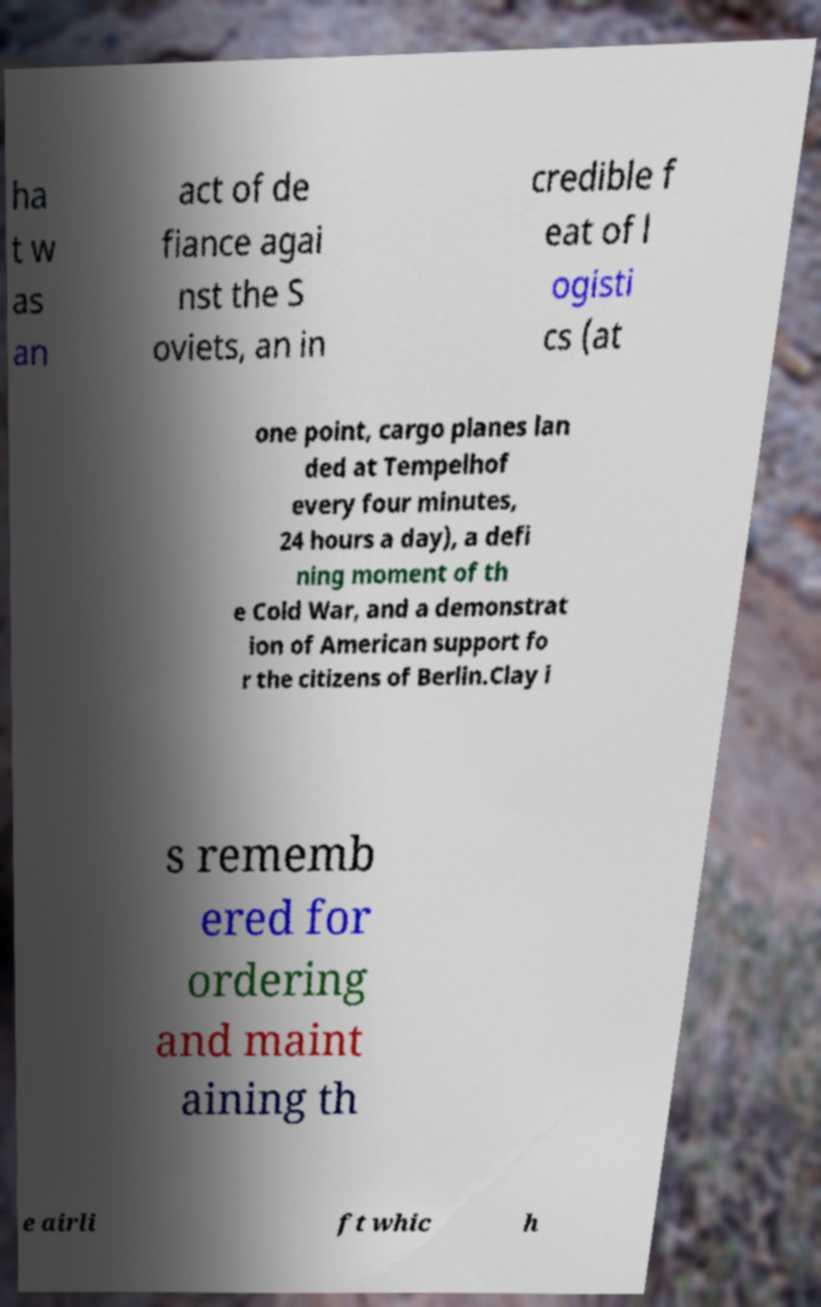Please identify and transcribe the text found in this image. ha t w as an act of de fiance agai nst the S oviets, an in credible f eat of l ogisti cs (at one point, cargo planes lan ded at Tempelhof every four minutes, 24 hours a day), a defi ning moment of th e Cold War, and a demonstrat ion of American support fo r the citizens of Berlin.Clay i s rememb ered for ordering and maint aining th e airli ft whic h 